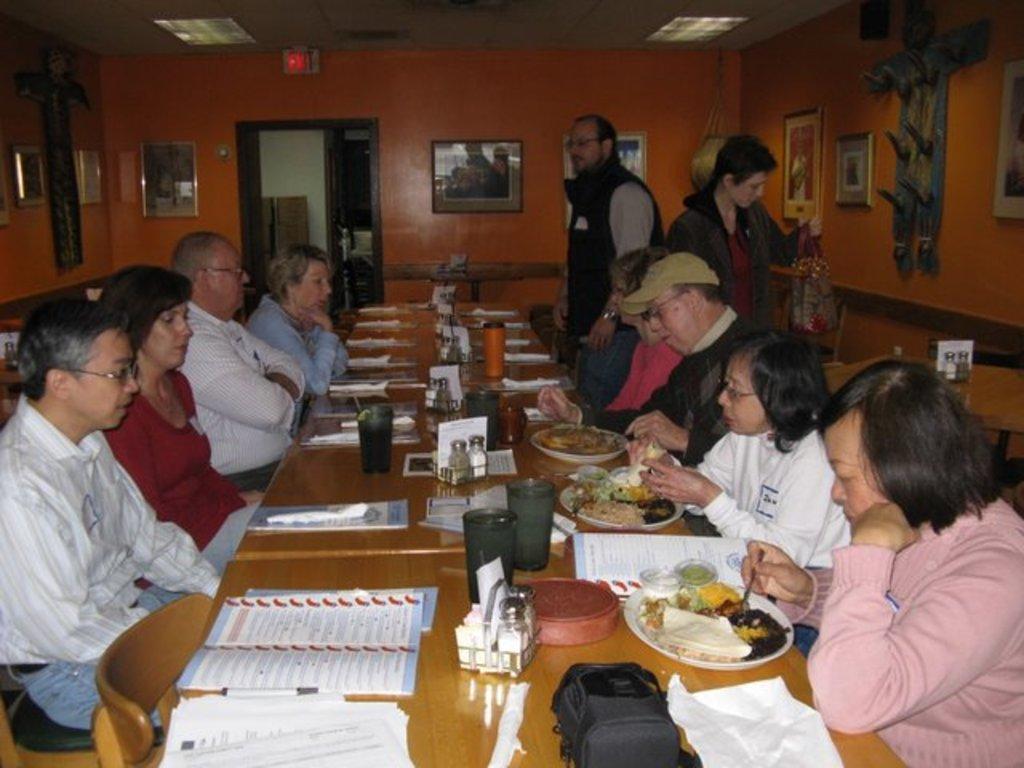In one or two sentences, can you explain what this image depicts? In this image, there is an inside view of a room. there are some persons wearing clothes and sitting in front of the table. This table contains plates, glasses, bag and some papers. There are some photo frames at the top of the image. 